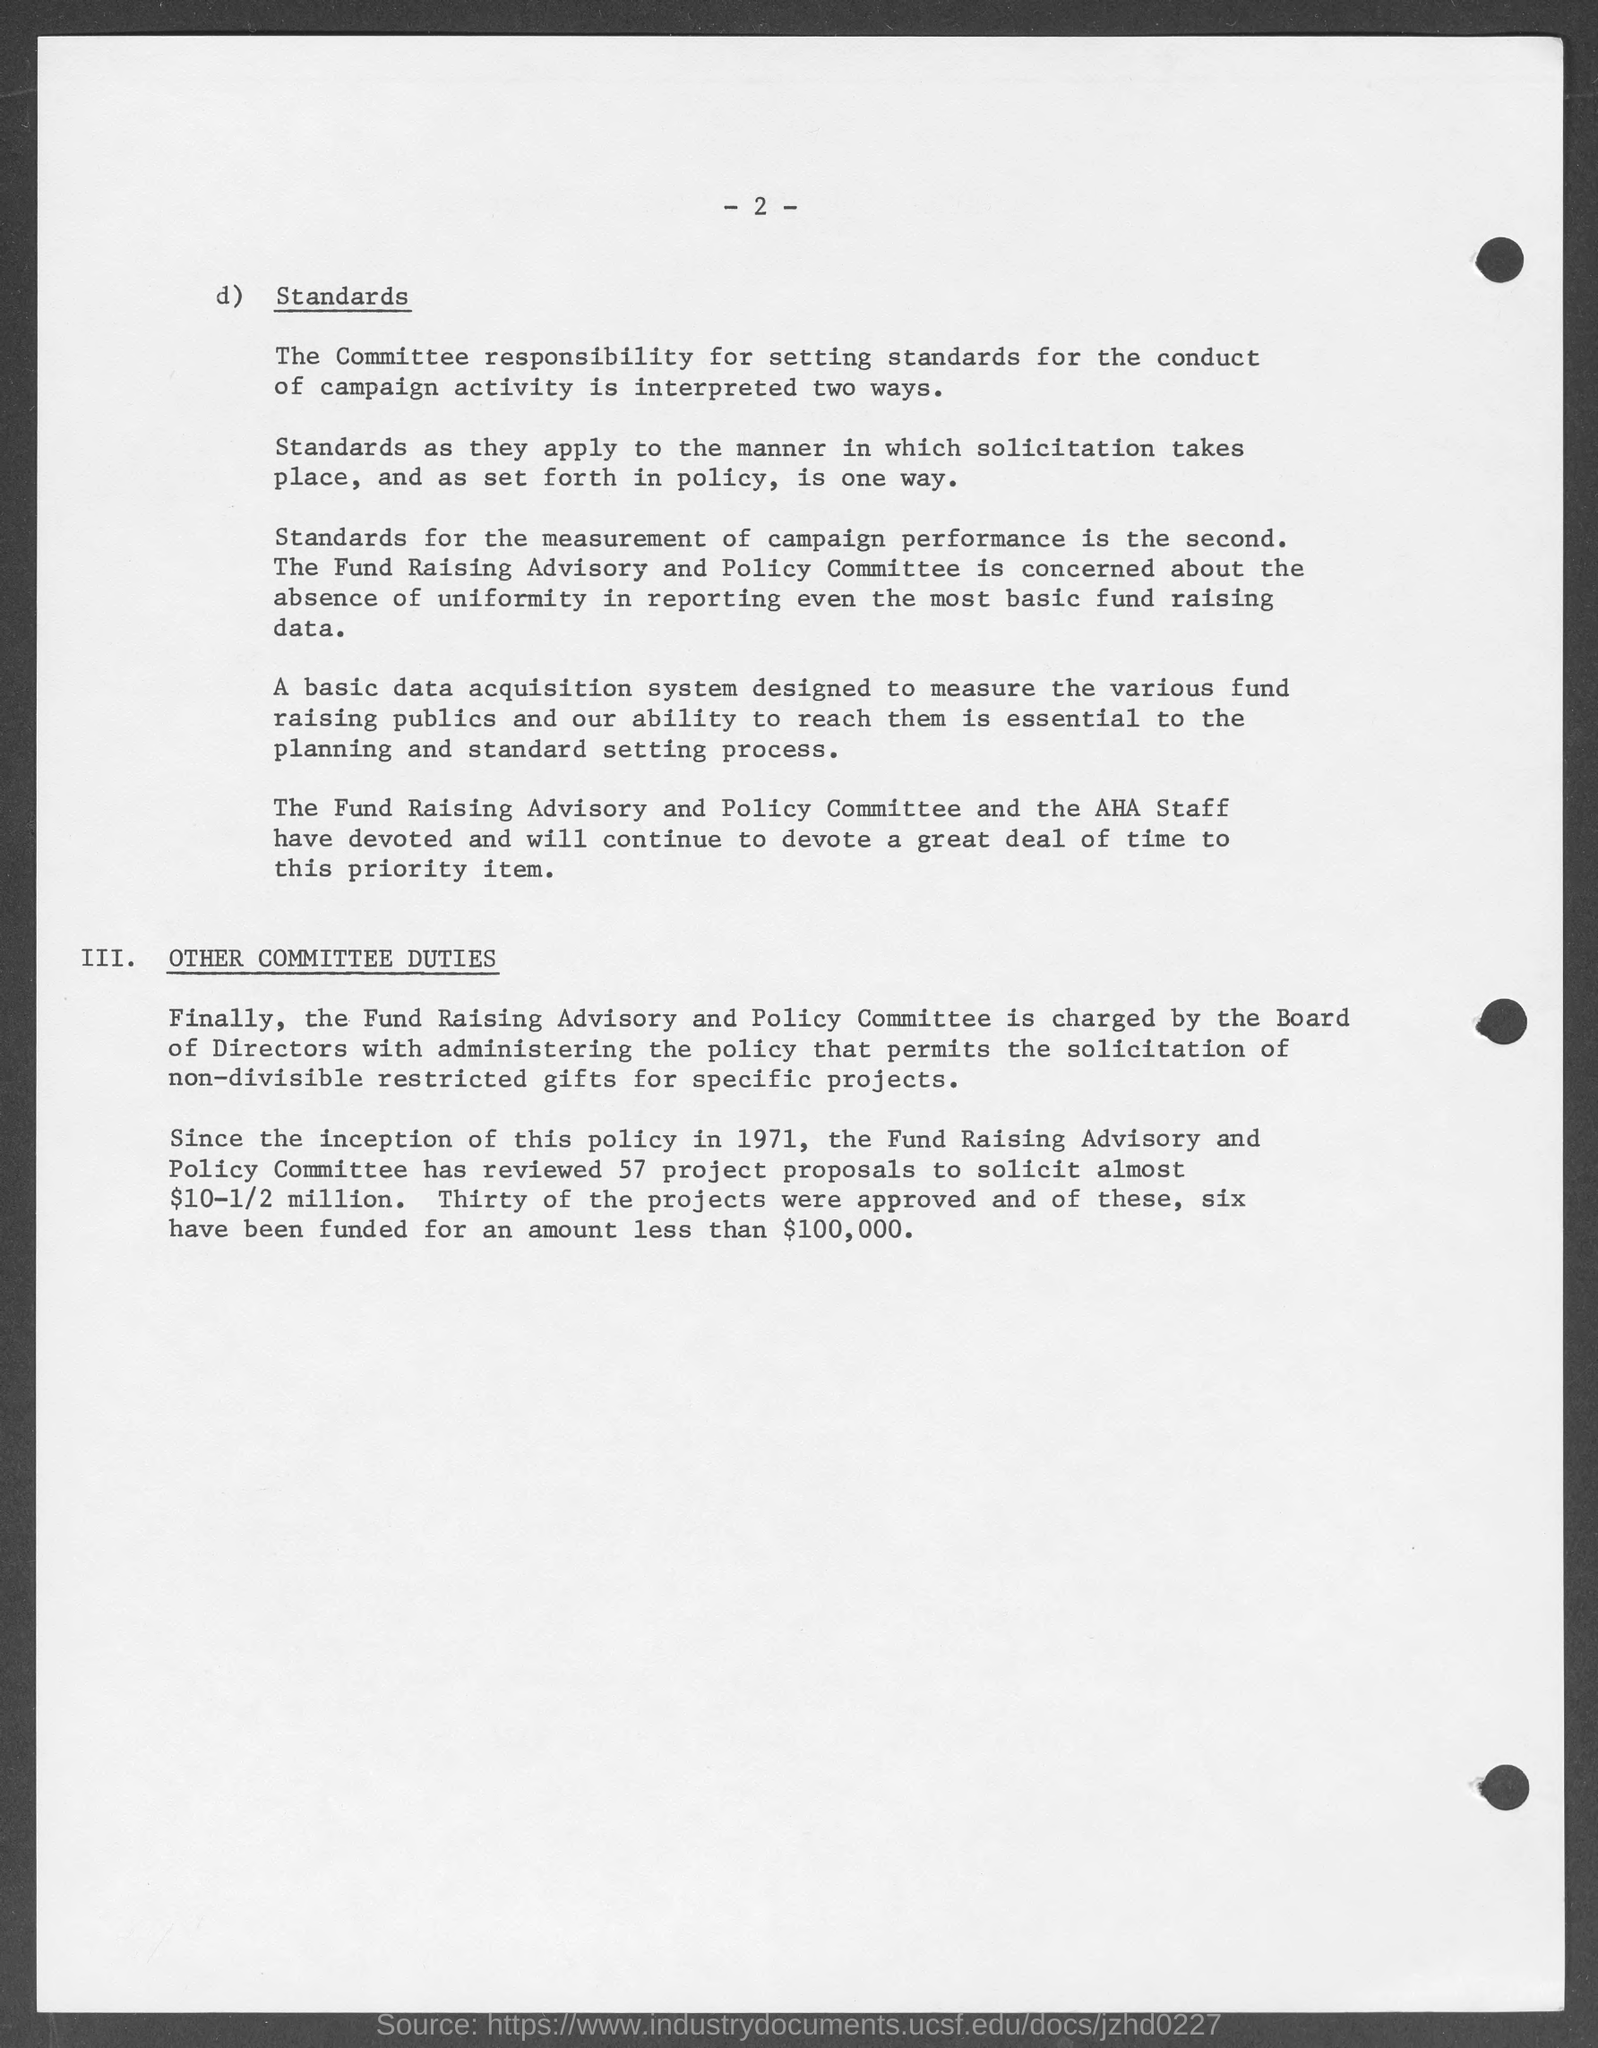What is the page no mentioned in this document?
Provide a succinct answer. 2. 